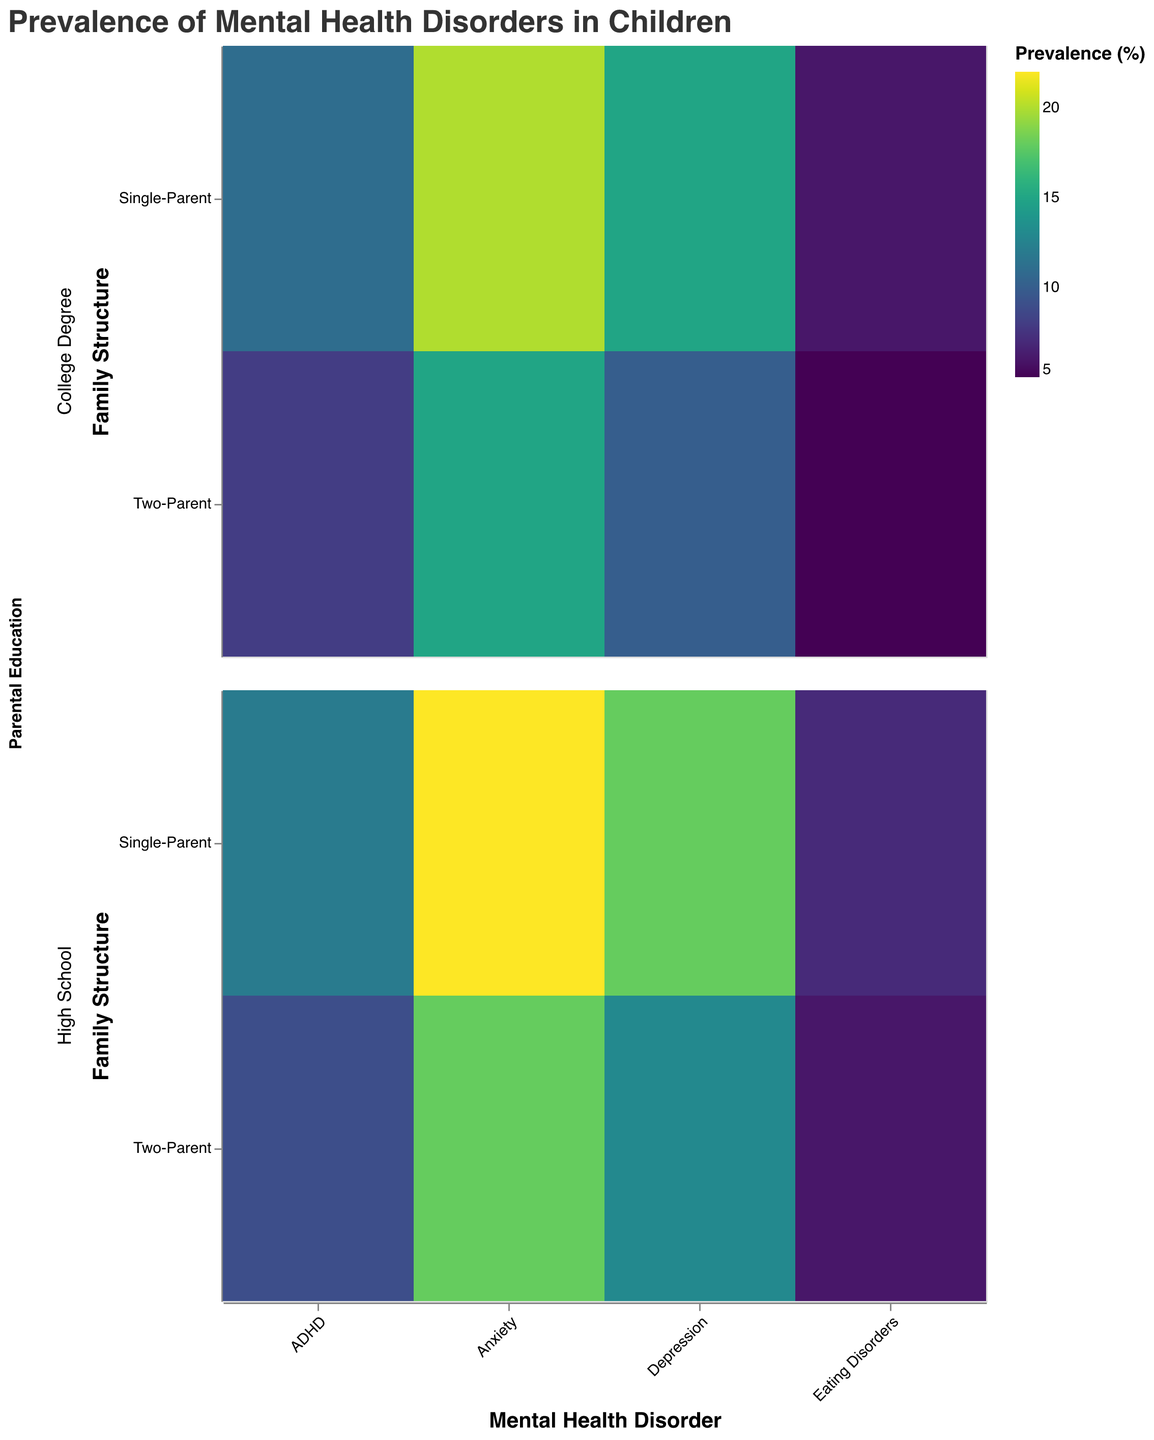What is the overall prevalence of anxiety in children from single-parent families with a high school education? The plot shows that the prevalence of anxiety in single-parent families with a high school education is directly shown as a percentage. This value is noted in the plot itself.
Answer: 22% Which mental health disorder has the highest prevalence in children from two-parent families with a college degree? Looking at the color intensity and the tooltip info for two-parent families with a college degree, check each mental disorder and find the one with the highest prevalence.
Answer: Anxiety How does the prevalence of ADHD in two-parent families with a high school education compare to those with a college degree? Compare the rectangles representing ADHD for two-parent families under high school education and college degrees by examining the colors and tooltip values.
Answer: Higher in high school education What is the difference in the prevalence of depression between single-parent families with different educational levels? Check the tooltip or color intensity for depression in single-parent families with high school and college degrees, then subtract to find the difference.
Answer: 3% In which parental education category do eating disorders have the same prevalence in both family structures? Check the rectangles for eating disorders under each parental education category and verify if the prevalence values are the same for both two-parent and single-parent families.
Answer: College Degree What is the general trend in the prevalence of mental health disorders concerning parental education in single-parent families? Examine the color intensities across disorders within the single-parent category, comparing high school and college degree groups for any patterns.
Answer: Higher in high school education Which mental health disorder has the lowest prevalence in two-parent families, regardless of parental education? For two-parent families, scrutinize the colors and tooltip values across all disorders to find the one with the lowest prevalence.
Answer: Eating Disorders What is the average prevalence of ADHD in single-parent families? Identify the prevalence values for ADHD in single-parent families from both educational backgrounds and calculate their average: (12+11)/2.
Answer: 11.5 Compare the prevalence of anxiety in children from two-parent families with a high school education to depression in the same subgroup. Look at the specific values for anxiety and depression in two-parent families under high school education and compare them directly.
Answer: Anxiety is higher How does parental education impact the prevalence of anxiety in single-parent families? Examine the prevalence percentages of anxiety in single-parent families for both high school and college degrees, noting any differences.
Answer: Higher in high school education 